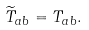<formula> <loc_0><loc_0><loc_500><loc_500>\widetilde { T } _ { a b } = T _ { a b } .</formula> 